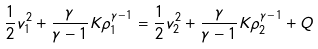<formula> <loc_0><loc_0><loc_500><loc_500>\frac { 1 } { 2 } v _ { 1 } ^ { 2 } + \frac { \gamma } { \gamma - 1 } K \rho _ { 1 } ^ { \gamma - 1 } = \frac { 1 } { 2 } v _ { 2 } ^ { 2 } + \frac { \gamma } { \gamma - 1 } K \rho _ { 2 } ^ { \gamma - 1 } + Q</formula> 